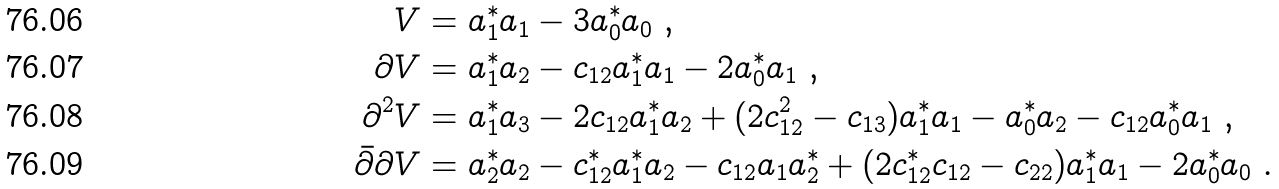Convert formula to latex. <formula><loc_0><loc_0><loc_500><loc_500>V & = a _ { 1 } ^ { * } a _ { 1 } - 3 a _ { 0 } ^ { * } a _ { 0 } \ , \\ \partial V & = a _ { 1 } ^ { * } a _ { 2 } - c _ { 1 2 } a _ { 1 } ^ { * } a _ { 1 } - 2 a _ { 0 } ^ { * } a _ { 1 } \ , \\ \partial ^ { 2 } V & = a _ { 1 } ^ { * } a _ { 3 } - 2 c _ { 1 2 } a _ { 1 } ^ { * } a _ { 2 } + ( 2 c _ { 1 2 } ^ { 2 } - c _ { 1 3 } ) a _ { 1 } ^ { * } a _ { 1 } - a _ { 0 } ^ { * } a _ { 2 } - c _ { 1 2 } a _ { 0 } ^ { * } a _ { 1 } \ , \\ \bar { \partial } \partial V & = a _ { 2 } ^ { * } a _ { 2 } - c _ { 1 2 } ^ { * } a _ { 1 } ^ { * } a _ { 2 } - c _ { 1 2 } a _ { 1 } a _ { 2 } ^ { * } + ( 2 c _ { 1 2 } ^ { * } c _ { 1 2 } - c _ { 2 2 } ) a _ { 1 } ^ { * } a _ { 1 } - 2 a _ { 0 } ^ { * } a _ { 0 } \ .</formula> 